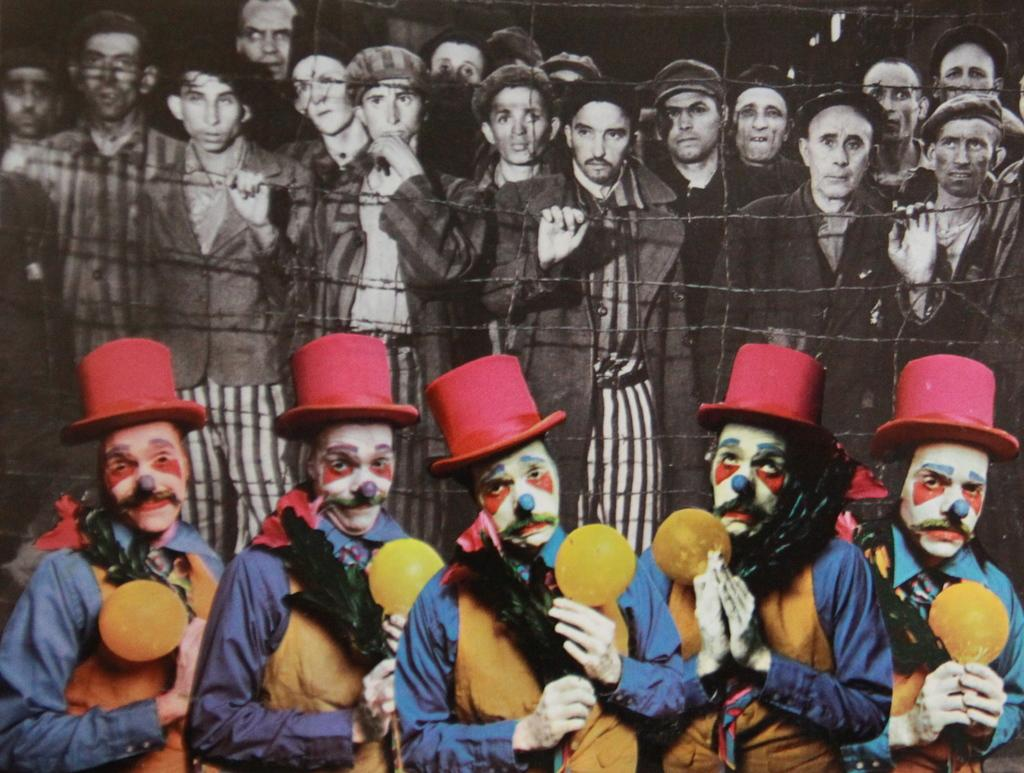What is happening with the people in the image? There are people standing behind the fence in the image. Are the people dressed in any specific way? Some people are wearing costumes in the image. What are the people in costumes doing? The people in costumes are holding objects in the image. What type of card can be seen being used by the people in the image? There is no card present in the image; the people in costumes are holding objects, but none of them resemble a card. 